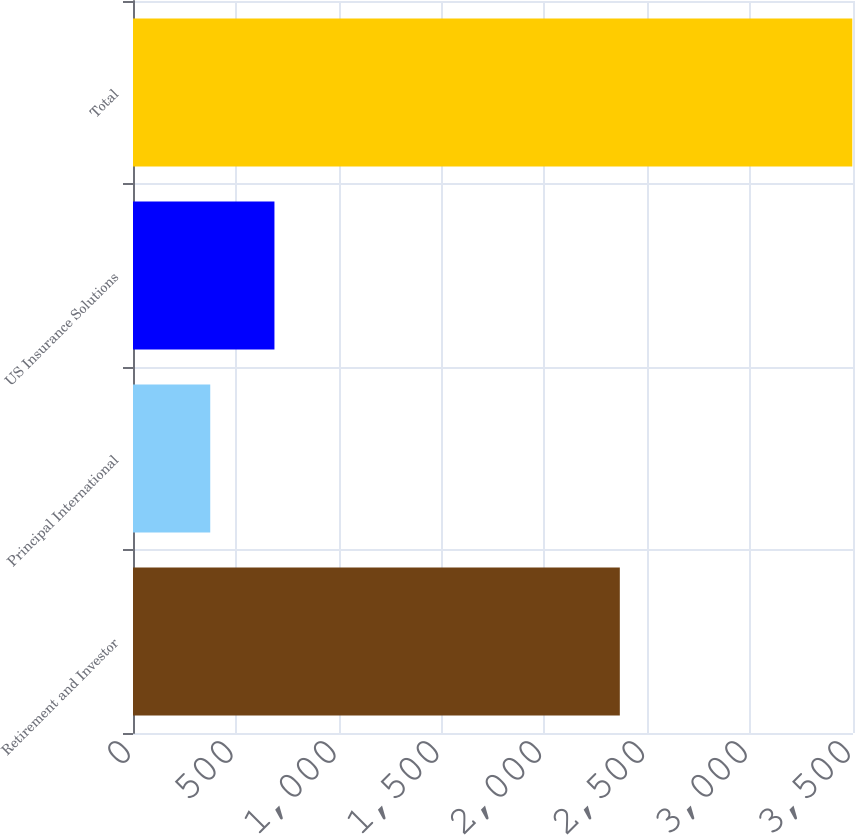<chart> <loc_0><loc_0><loc_500><loc_500><bar_chart><fcel>Retirement and Investor<fcel>Principal International<fcel>US Insurance Solutions<fcel>Total<nl><fcel>2366.5<fcel>375.5<fcel>687.6<fcel>3496.5<nl></chart> 